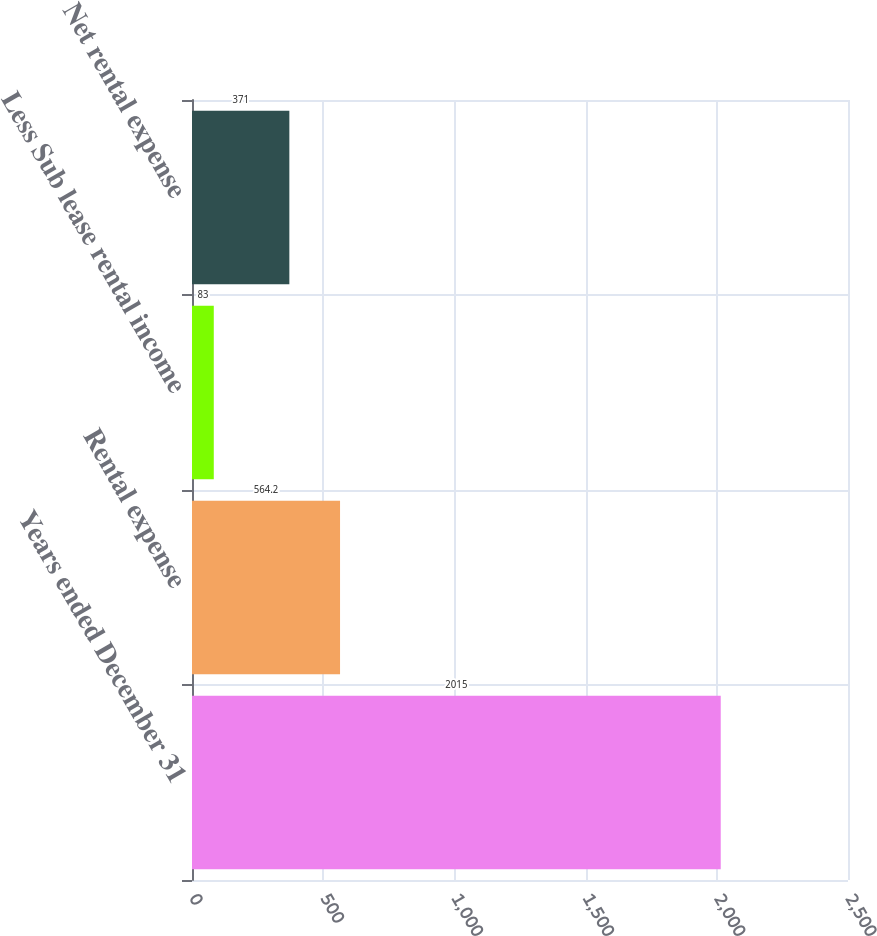Convert chart to OTSL. <chart><loc_0><loc_0><loc_500><loc_500><bar_chart><fcel>Years ended December 31<fcel>Rental expense<fcel>Less Sub lease rental income<fcel>Net rental expense<nl><fcel>2015<fcel>564.2<fcel>83<fcel>371<nl></chart> 